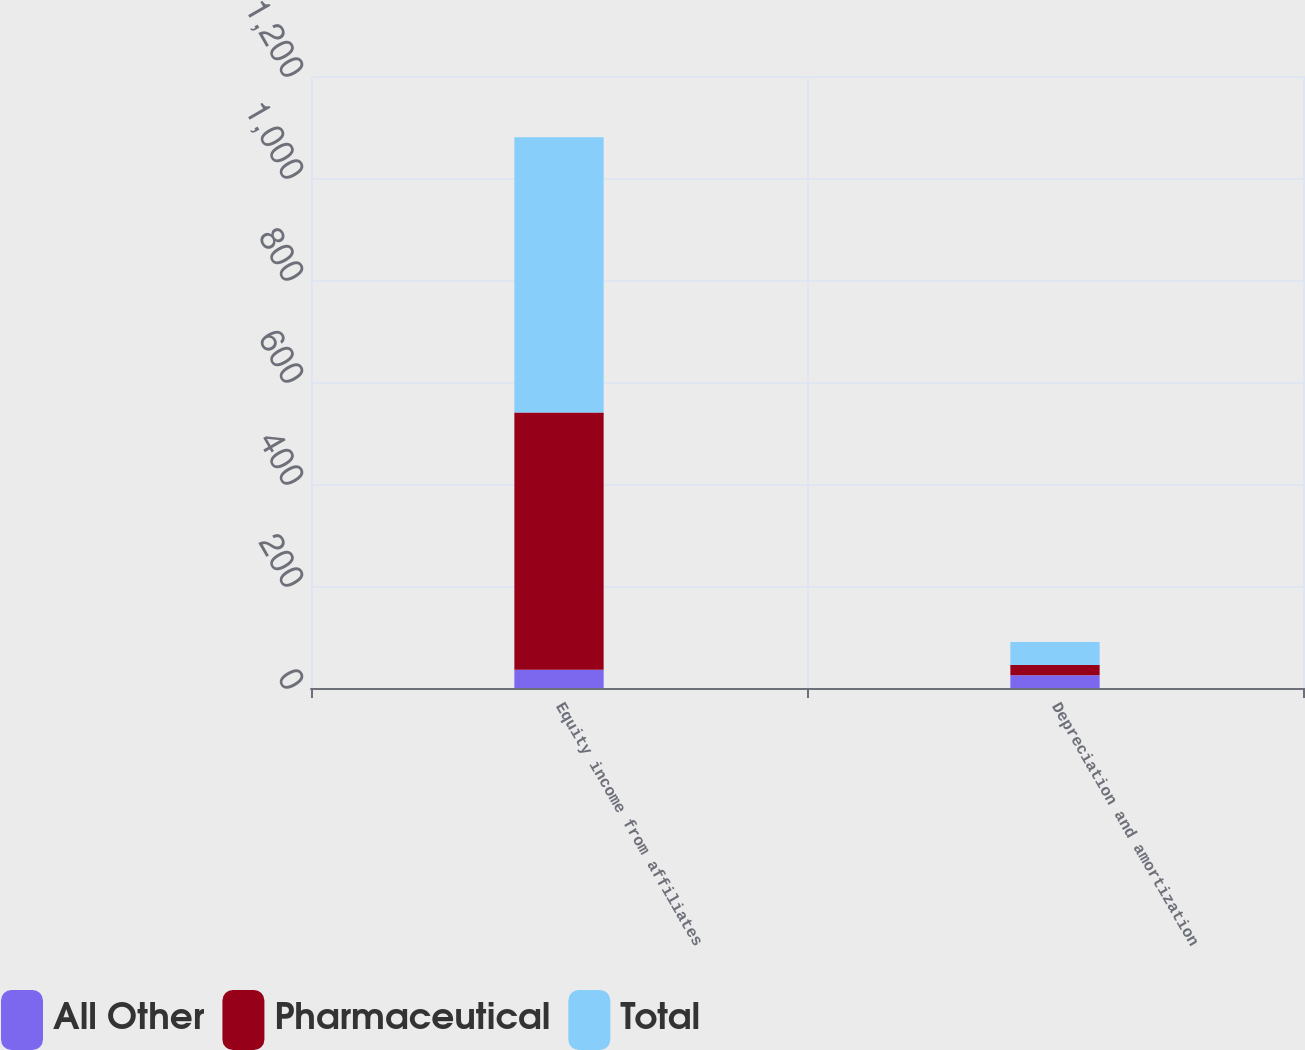Convert chart to OTSL. <chart><loc_0><loc_0><loc_500><loc_500><stacked_bar_chart><ecel><fcel>Equity income from affiliates<fcel>Depreciation and amortization<nl><fcel>All Other<fcel>36<fcel>25<nl><fcel>Pharmaceutical<fcel>504<fcel>20<nl><fcel>Total<fcel>540<fcel>45<nl></chart> 